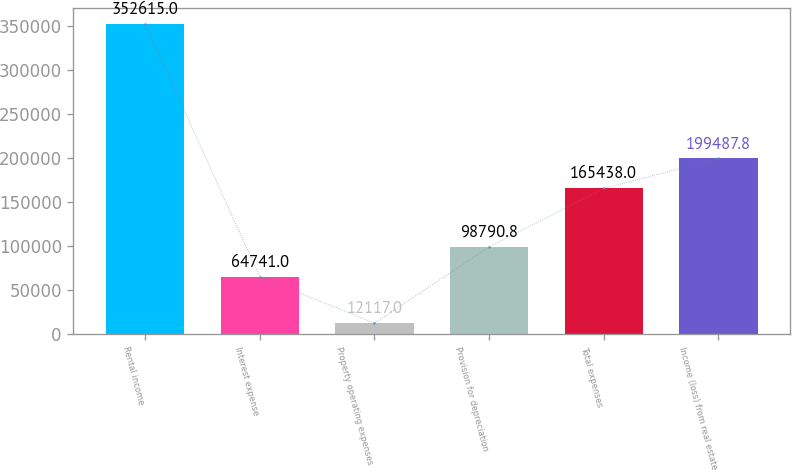Convert chart to OTSL. <chart><loc_0><loc_0><loc_500><loc_500><bar_chart><fcel>Rental income<fcel>Interest expense<fcel>Property operating expenses<fcel>Provision for depreciation<fcel>Total expenses<fcel>Income (loss) from real estate<nl><fcel>352615<fcel>64741<fcel>12117<fcel>98790.8<fcel>165438<fcel>199488<nl></chart> 